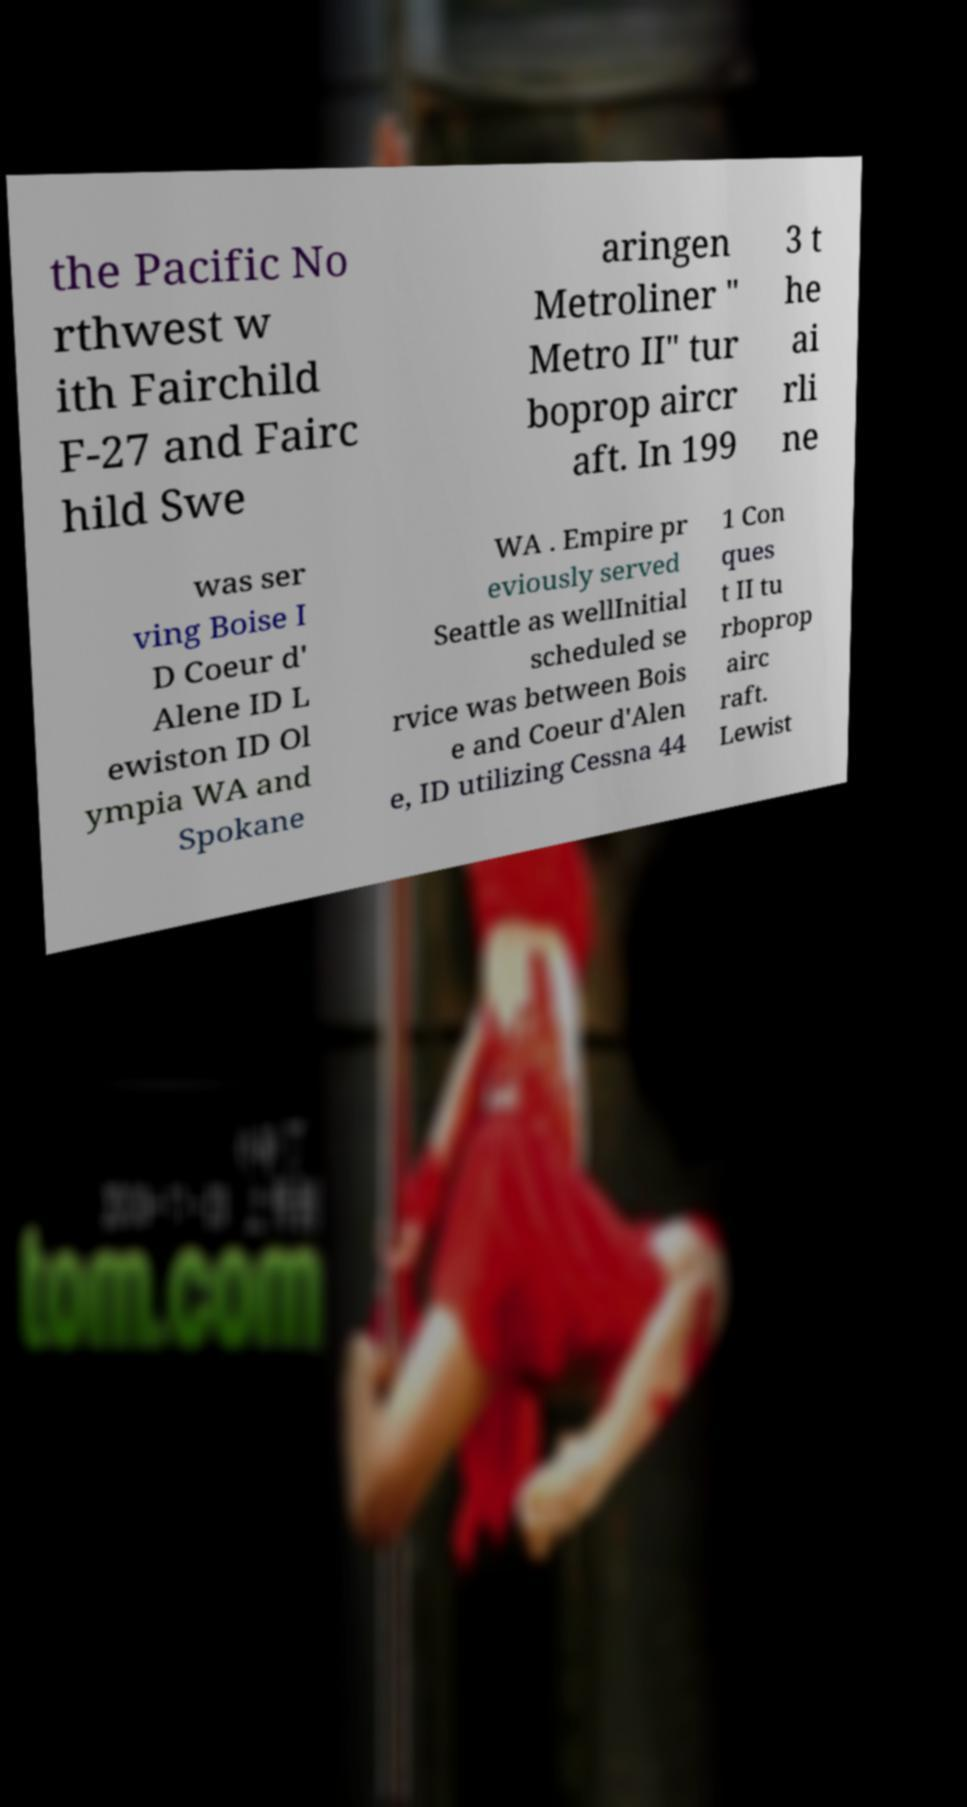Please read and relay the text visible in this image. What does it say? the Pacific No rthwest w ith Fairchild F-27 and Fairc hild Swe aringen Metroliner " Metro II" tur boprop aircr aft. In 199 3 t he ai rli ne was ser ving Boise I D Coeur d' Alene ID L ewiston ID Ol ympia WA and Spokane WA . Empire pr eviously served Seattle as wellInitial scheduled se rvice was between Bois e and Coeur d'Alen e, ID utilizing Cessna 44 1 Con ques t II tu rboprop airc raft. Lewist 